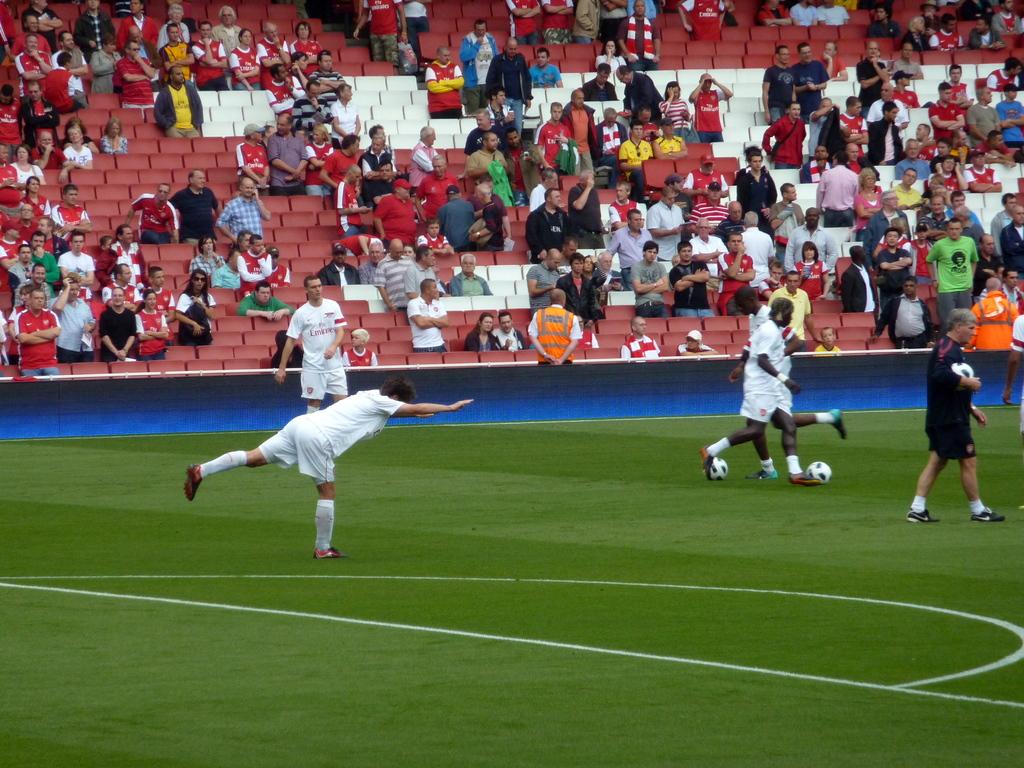What color lettering is on the white jerseys?
Your response must be concise. Answering does not require reading text in the image. 